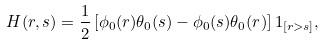<formula> <loc_0><loc_0><loc_500><loc_500>H ( r , s ) = \frac { 1 } { 2 } \left [ \phi _ { 0 } ( r ) \theta _ { 0 } ( s ) - \phi _ { 0 } ( s ) \theta _ { 0 } ( r ) \right ] 1 _ { [ r > s ] } ,</formula> 